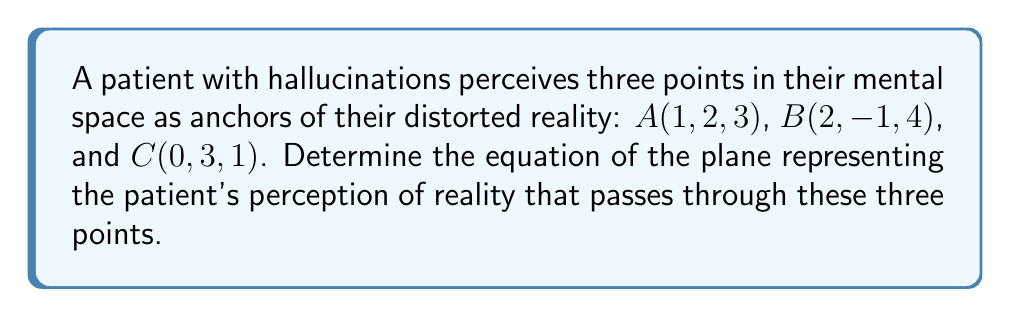What is the answer to this math problem? To find the equation of a plane passing through three points, we can follow these steps:

1) First, we need to find two vectors on the plane. We can do this by subtracting the coordinates of two points from the third:

   $\vec{AB} = B - A = (2-1, -1-2, 4-3) = (1, -3, 1)$
   $\vec{AC} = C - A = (0-1, 3-2, 1-3) = (-1, 1, -2)$

2) The normal vector to the plane will be the cross product of these two vectors:

   $\vec{n} = \vec{AB} \times \vec{AC} = \begin{vmatrix} 
   i & j & k \\
   1 & -3 & 1 \\
   -1 & 1 & -2
   \end{vmatrix}$

   $= ((-3)(-2) - (1)(1))i - ((1)(-2) - (-1)(1))j + ((1)(1) - (-3)(-1))k$
   
   $= (6 - 1)i - (-2 - (-1))j + (1 - (-3))k$
   
   $= 5i - (-1)j + 4k$
   
   $\vec{n} = (5, 1, 4)$

3) The general equation of a plane is $ax + by + cz + d = 0$, where $(a, b, c)$ is the normal vector.

4) We can use point $A(1, 2, 3)$ to find $d$:

   $5(1) + 1(2) + 4(3) + d = 0$
   $5 + 2 + 12 + d = 0$
   $d = -19$

5) Therefore, the equation of the plane is:

   $5x + y + 4z - 19 = 0$

This equation represents the patient's perceived reality plane in their mental space.
Answer: $5x + y + 4z - 19 = 0$ 